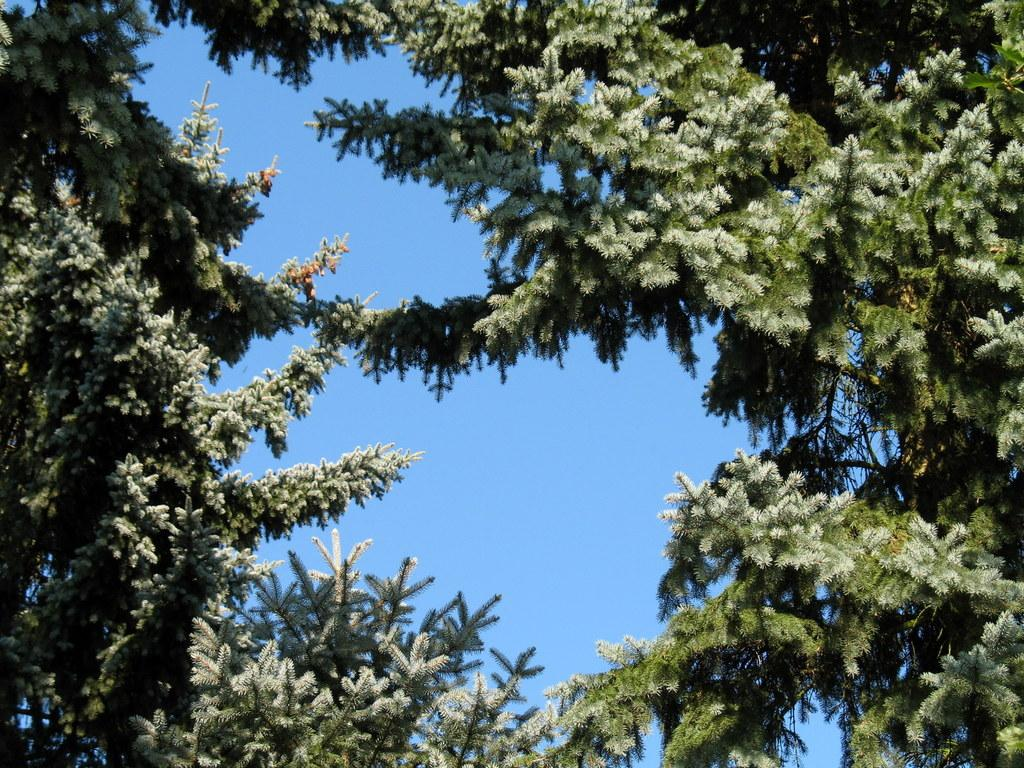What type of vegetation can be seen in the image? There are leaves of trees in the image. What part of the natural environment is visible in the image? The sky is visible in the background of the image. What is the color of the sky in the image? The color of the sky is blue. Can you see any elbows in the image? There are no elbows present in the image, as it features leaves of trees and the sky. 